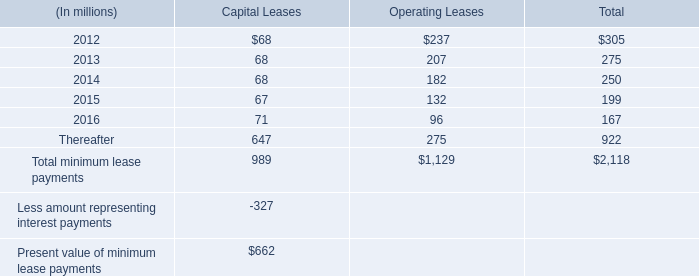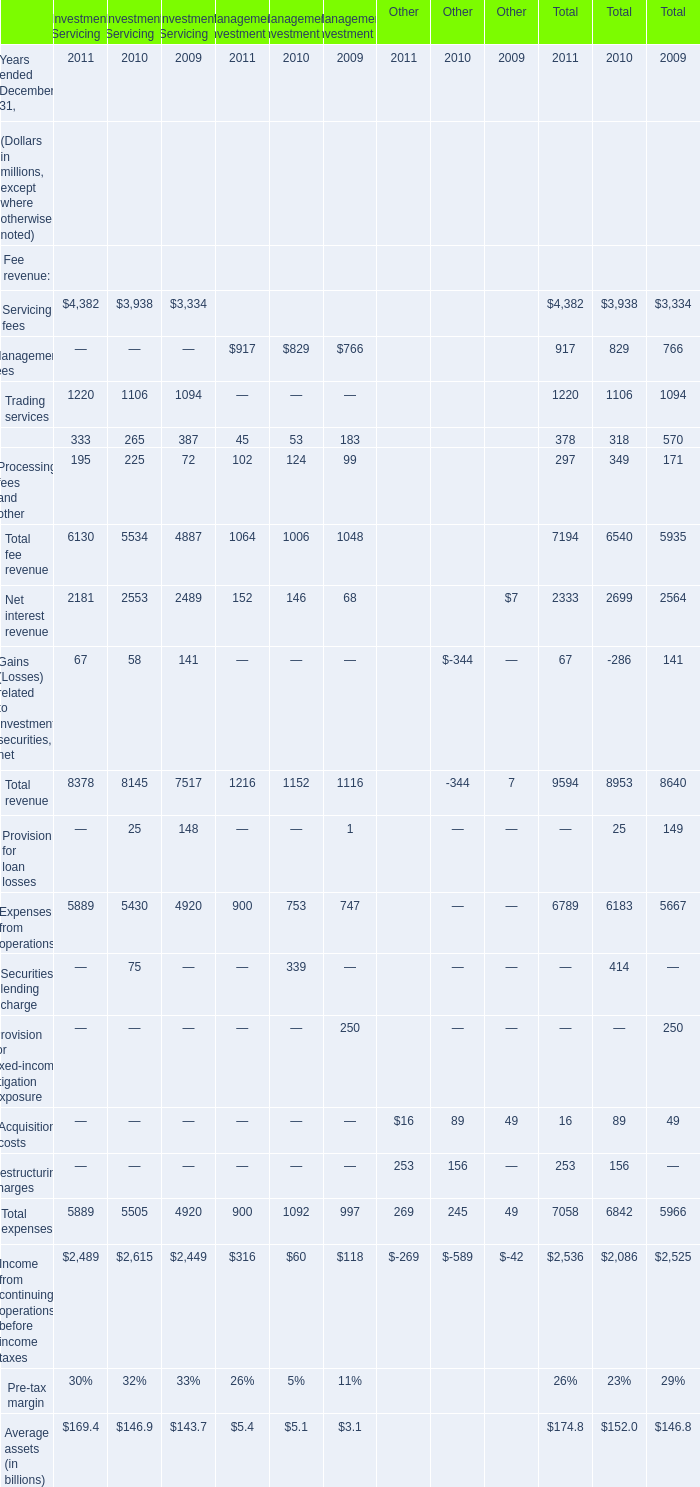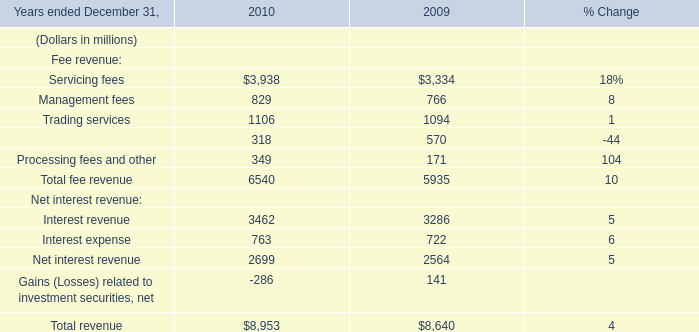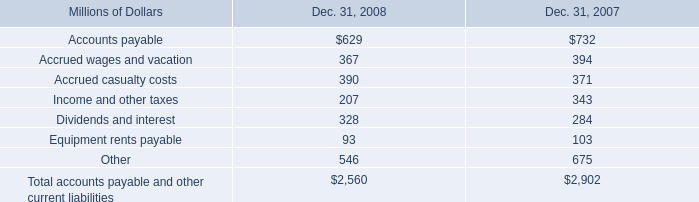what was the percentage change in accrued wages and vacation from 2007 to 2008? 
Computations: ((367 - 394) / 394)
Answer: -0.06853. 